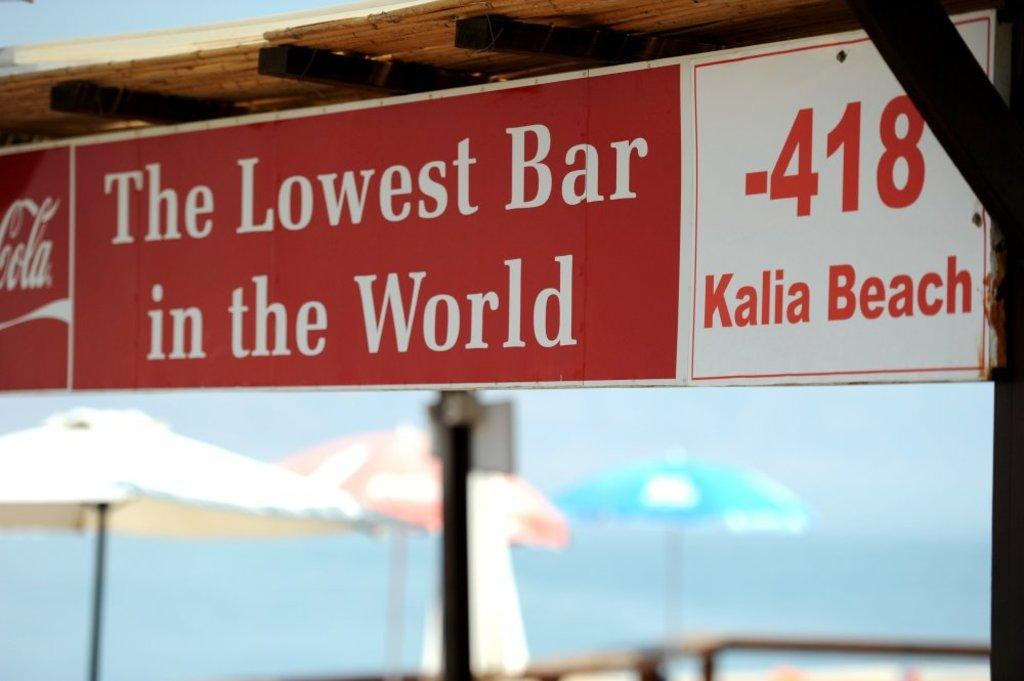What is attached to the roof in the image? There is a board fixed to the roof in the image. What can be seen in the background of the image? There are three umbrellas in the background of the image. What is written or displayed on the board? There is text on the board. What decision is being made by the pencil in the image? There is no pencil present in the image, so no decision can be made by a pencil. 